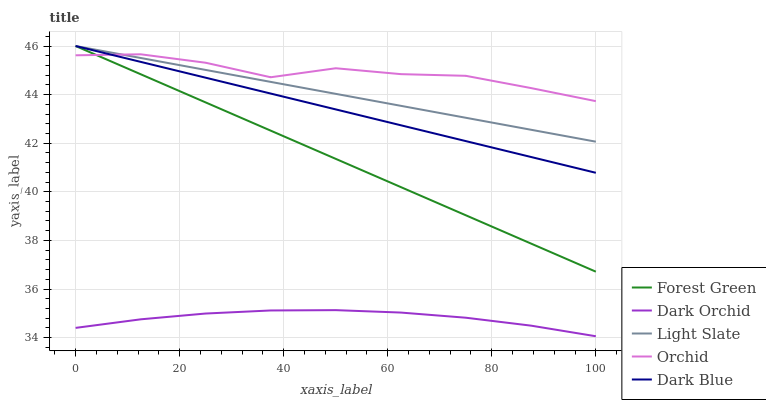Does Dark Orchid have the minimum area under the curve?
Answer yes or no. Yes. Does Orchid have the maximum area under the curve?
Answer yes or no. Yes. Does Dark Blue have the minimum area under the curve?
Answer yes or no. No. Does Dark Blue have the maximum area under the curve?
Answer yes or no. No. Is Light Slate the smoothest?
Answer yes or no. Yes. Is Orchid the roughest?
Answer yes or no. Yes. Is Dark Blue the smoothest?
Answer yes or no. No. Is Dark Blue the roughest?
Answer yes or no. No. Does Dark Blue have the lowest value?
Answer yes or no. No. Does Forest Green have the highest value?
Answer yes or no. Yes. Does Dark Orchid have the highest value?
Answer yes or no. No. Is Dark Orchid less than Forest Green?
Answer yes or no. Yes. Is Orchid greater than Dark Orchid?
Answer yes or no. Yes. Does Forest Green intersect Orchid?
Answer yes or no. Yes. Is Forest Green less than Orchid?
Answer yes or no. No. Is Forest Green greater than Orchid?
Answer yes or no. No. Does Dark Orchid intersect Forest Green?
Answer yes or no. No. 